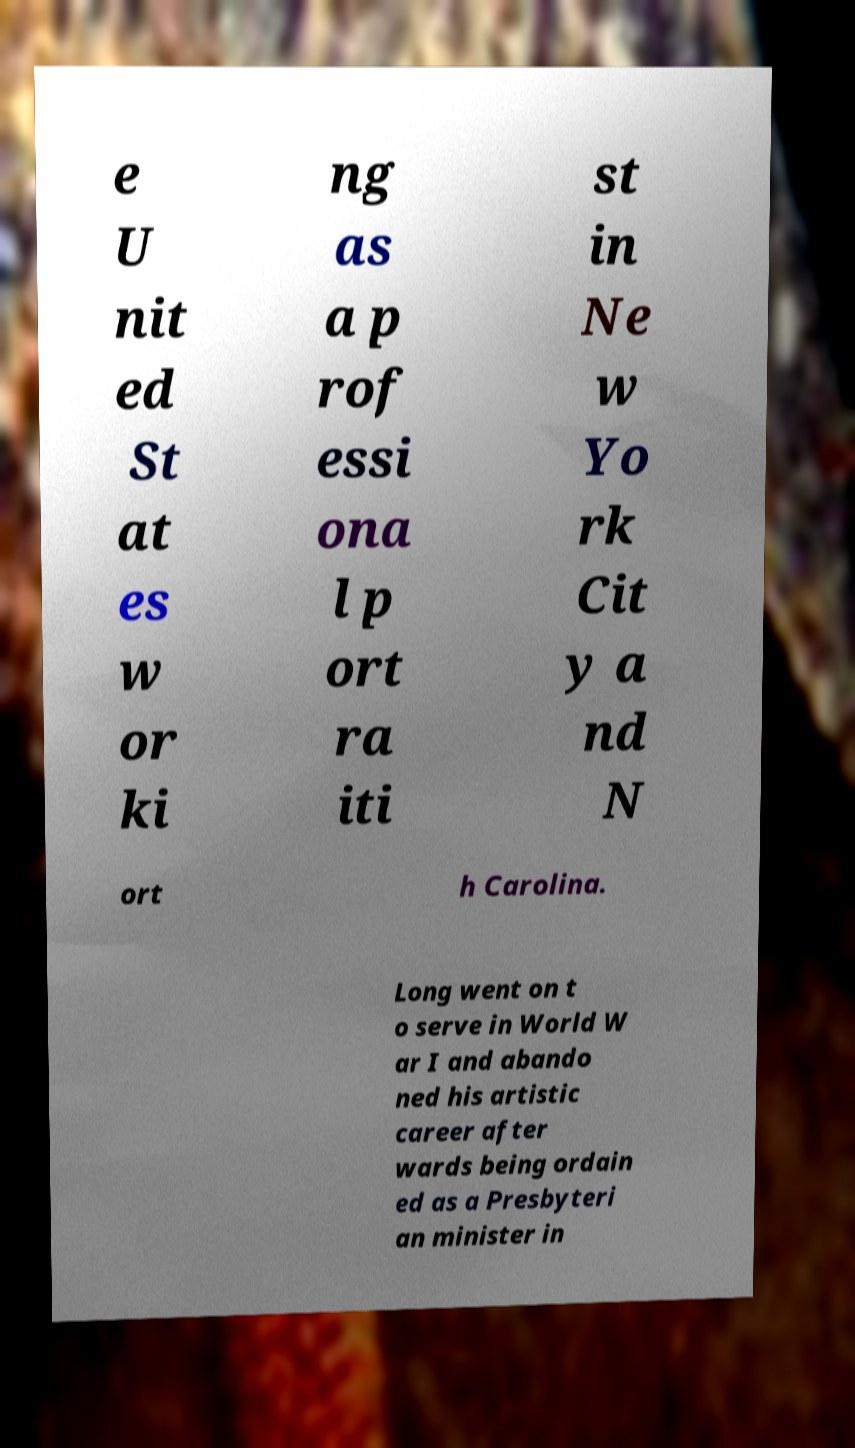Can you read and provide the text displayed in the image?This photo seems to have some interesting text. Can you extract and type it out for me? e U nit ed St at es w or ki ng as a p rof essi ona l p ort ra iti st in Ne w Yo rk Cit y a nd N ort h Carolina. Long went on t o serve in World W ar I and abando ned his artistic career after wards being ordain ed as a Presbyteri an minister in 